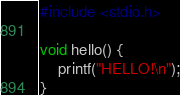<code> <loc_0><loc_0><loc_500><loc_500><_C_>#include <stdio.h>

void hello() {
    printf("HELLO!\n");
}</code> 